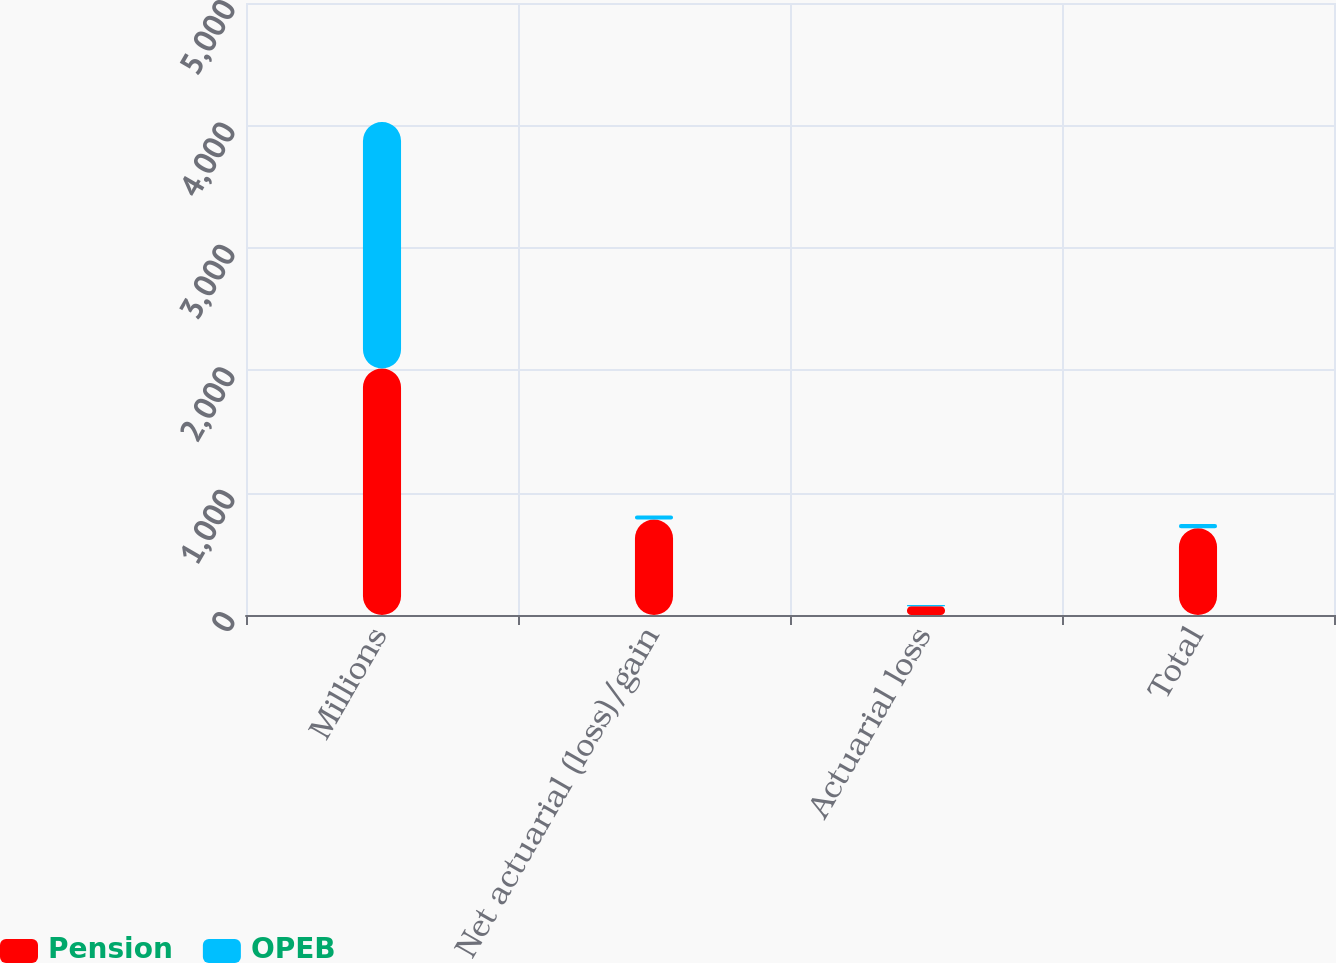<chart> <loc_0><loc_0><loc_500><loc_500><stacked_bar_chart><ecel><fcel>Millions<fcel>Net actuarial (loss)/gain<fcel>Actuarial loss<fcel>Total<nl><fcel>Pension<fcel>2014<fcel>780<fcel>71<fcel>709<nl><fcel>OPEB<fcel>2014<fcel>33<fcel>10<fcel>34<nl></chart> 